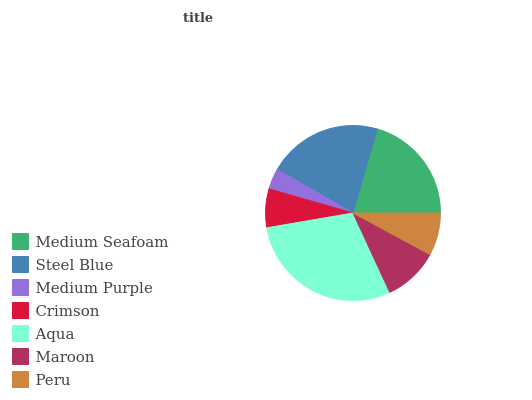Is Medium Purple the minimum?
Answer yes or no. Yes. Is Aqua the maximum?
Answer yes or no. Yes. Is Steel Blue the minimum?
Answer yes or no. No. Is Steel Blue the maximum?
Answer yes or no. No. Is Steel Blue greater than Medium Seafoam?
Answer yes or no. Yes. Is Medium Seafoam less than Steel Blue?
Answer yes or no. Yes. Is Medium Seafoam greater than Steel Blue?
Answer yes or no. No. Is Steel Blue less than Medium Seafoam?
Answer yes or no. No. Is Maroon the high median?
Answer yes or no. Yes. Is Maroon the low median?
Answer yes or no. Yes. Is Medium Purple the high median?
Answer yes or no. No. Is Steel Blue the low median?
Answer yes or no. No. 